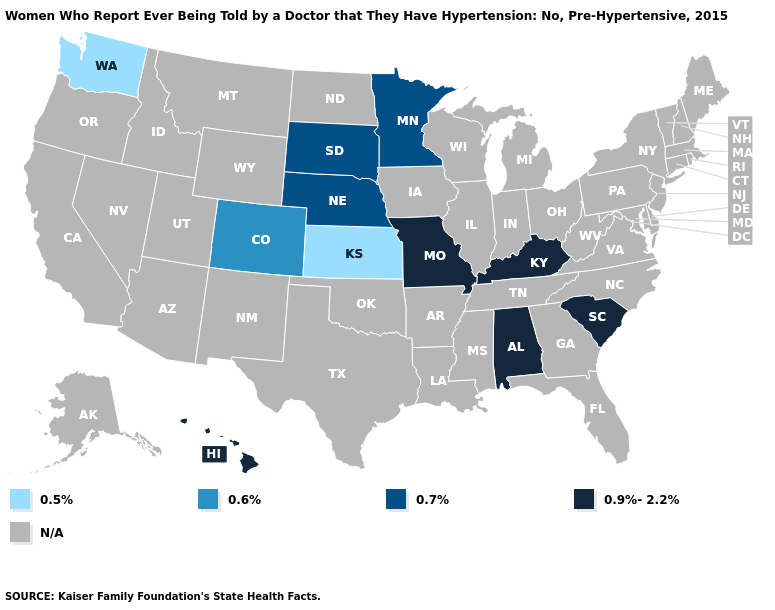What is the lowest value in the USA?
Give a very brief answer. 0.5%. Does Colorado have the lowest value in the West?
Quick response, please. No. Name the states that have a value in the range N/A?
Quick response, please. Alaska, Arizona, Arkansas, California, Connecticut, Delaware, Florida, Georgia, Idaho, Illinois, Indiana, Iowa, Louisiana, Maine, Maryland, Massachusetts, Michigan, Mississippi, Montana, Nevada, New Hampshire, New Jersey, New Mexico, New York, North Carolina, North Dakota, Ohio, Oklahoma, Oregon, Pennsylvania, Rhode Island, Tennessee, Texas, Utah, Vermont, Virginia, West Virginia, Wisconsin, Wyoming. Name the states that have a value in the range 0.9%-2.2%?
Keep it brief. Alabama, Hawaii, Kentucky, Missouri, South Carolina. What is the lowest value in the USA?
Concise answer only. 0.5%. Name the states that have a value in the range N/A?
Be succinct. Alaska, Arizona, Arkansas, California, Connecticut, Delaware, Florida, Georgia, Idaho, Illinois, Indiana, Iowa, Louisiana, Maine, Maryland, Massachusetts, Michigan, Mississippi, Montana, Nevada, New Hampshire, New Jersey, New Mexico, New York, North Carolina, North Dakota, Ohio, Oklahoma, Oregon, Pennsylvania, Rhode Island, Tennessee, Texas, Utah, Vermont, Virginia, West Virginia, Wisconsin, Wyoming. What is the highest value in states that border Arkansas?
Quick response, please. 0.9%-2.2%. Which states have the lowest value in the USA?
Give a very brief answer. Kansas, Washington. What is the value of Hawaii?
Quick response, please. 0.9%-2.2%. What is the value of Arkansas?
Give a very brief answer. N/A. What is the value of Maryland?
Be succinct. N/A. What is the value of New Hampshire?
Quick response, please. N/A. Name the states that have a value in the range N/A?
Write a very short answer. Alaska, Arizona, Arkansas, California, Connecticut, Delaware, Florida, Georgia, Idaho, Illinois, Indiana, Iowa, Louisiana, Maine, Maryland, Massachusetts, Michigan, Mississippi, Montana, Nevada, New Hampshire, New Jersey, New Mexico, New York, North Carolina, North Dakota, Ohio, Oklahoma, Oregon, Pennsylvania, Rhode Island, Tennessee, Texas, Utah, Vermont, Virginia, West Virginia, Wisconsin, Wyoming. Name the states that have a value in the range 0.7%?
Give a very brief answer. Minnesota, Nebraska, South Dakota. 